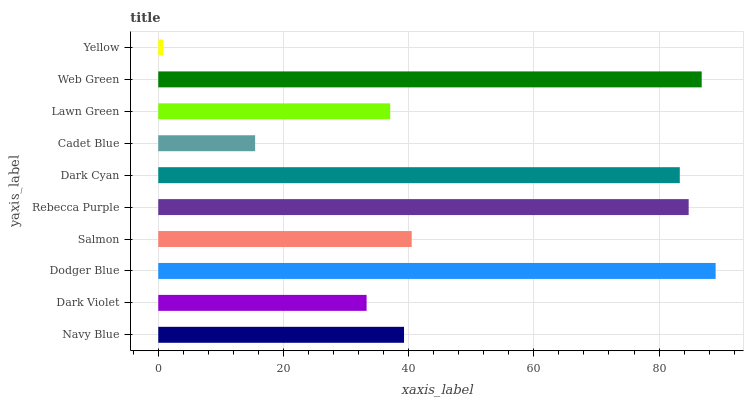Is Yellow the minimum?
Answer yes or no. Yes. Is Dodger Blue the maximum?
Answer yes or no. Yes. Is Dark Violet the minimum?
Answer yes or no. No. Is Dark Violet the maximum?
Answer yes or no. No. Is Navy Blue greater than Dark Violet?
Answer yes or no. Yes. Is Dark Violet less than Navy Blue?
Answer yes or no. Yes. Is Dark Violet greater than Navy Blue?
Answer yes or no. No. Is Navy Blue less than Dark Violet?
Answer yes or no. No. Is Salmon the high median?
Answer yes or no. Yes. Is Navy Blue the low median?
Answer yes or no. Yes. Is Navy Blue the high median?
Answer yes or no. No. Is Web Green the low median?
Answer yes or no. No. 